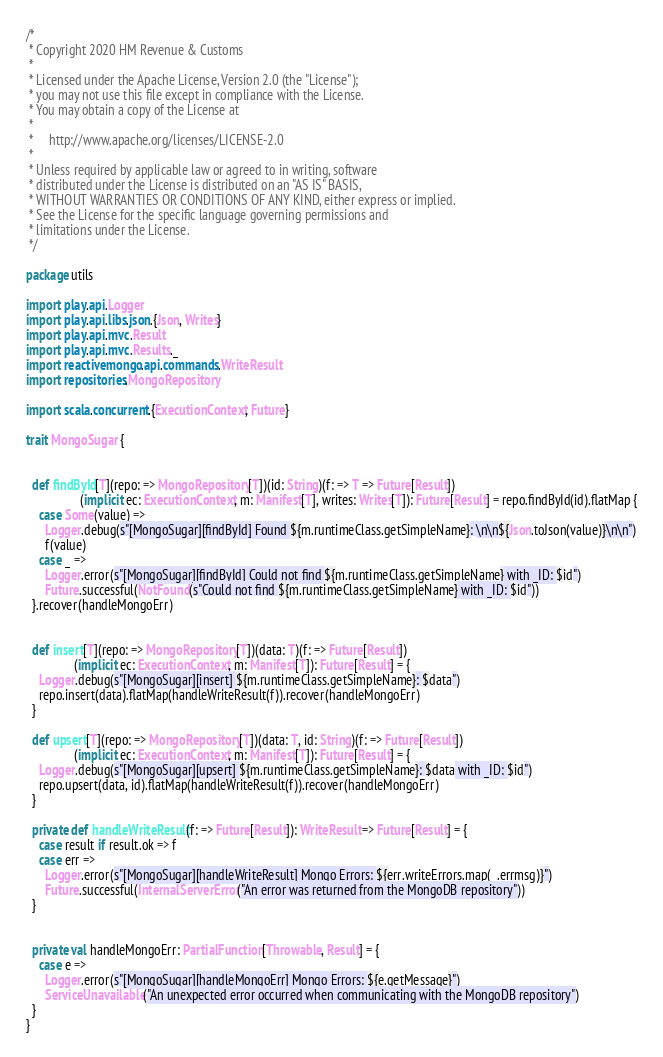Convert code to text. <code><loc_0><loc_0><loc_500><loc_500><_Scala_>/*
 * Copyright 2020 HM Revenue & Customs
 *
 * Licensed under the Apache License, Version 2.0 (the "License");
 * you may not use this file except in compliance with the License.
 * You may obtain a copy of the License at
 *
 *     http://www.apache.org/licenses/LICENSE-2.0
 *
 * Unless required by applicable law or agreed to in writing, software
 * distributed under the License is distributed on an "AS IS" BASIS,
 * WITHOUT WARRANTIES OR CONDITIONS OF ANY KIND, either express or implied.
 * See the License for the specific language governing permissions and
 * limitations under the License.
 */

package utils

import play.api.Logger
import play.api.libs.json.{Json, Writes}
import play.api.mvc.Result
import play.api.mvc.Results._
import reactivemongo.api.commands.WriteResult
import repositories.MongoRepository

import scala.concurrent.{ExecutionContext, Future}

trait MongoSugar {


  def findById[T](repo: => MongoRepository[T])(id: String)(f: => T => Future[Result])
                 (implicit ec: ExecutionContext, m: Manifest[T], writes: Writes[T]): Future[Result] = repo.findById(id).flatMap {
    case Some(value) =>
      Logger.debug(s"[MongoSugar][findById] Found ${m.runtimeClass.getSimpleName}: \n\n${Json.toJson(value)}\n\n")
      f(value)
    case _ =>
      Logger.error(s"[MongoSugar][findById] Could not find ${m.runtimeClass.getSimpleName} with _ID: $id")
      Future.successful(NotFound(s"Could not find ${m.runtimeClass.getSimpleName} with _ID: $id"))
  }.recover(handleMongoErr)


  def insert[T](repo: => MongoRepository[T])(data: T)(f: => Future[Result])
               (implicit ec: ExecutionContext, m: Manifest[T]): Future[Result] = {
    Logger.debug(s"[MongoSugar][insert] ${m.runtimeClass.getSimpleName}: $data")
    repo.insert(data).flatMap(handleWriteResult(f)).recover(handleMongoErr)
  }

  def upsert[T](repo: => MongoRepository[T])(data: T, id: String)(f: => Future[Result])
               (implicit ec: ExecutionContext, m: Manifest[T]): Future[Result] = {
    Logger.debug(s"[MongoSugar][upsert] ${m.runtimeClass.getSimpleName}: $data with _ID: $id")
    repo.upsert(data, id).flatMap(handleWriteResult(f)).recover(handleMongoErr)
  }

  private def handleWriteResult(f: => Future[Result]): WriteResult => Future[Result] = {
    case result if result.ok => f
    case err =>
      Logger.error(s"[MongoSugar][handleWriteResult] Mongo Errors: ${err.writeErrors.map(_.errmsg)}")
      Future.successful(InternalServerError("An error was returned from the MongoDB repository"))
  }


  private val handleMongoErr: PartialFunction[Throwable, Result] = {
    case e =>
      Logger.error(s"[MongoSugar][handleMongoErr] Mongo Errors: ${e.getMessage}")
      ServiceUnavailable("An unexpected error occurred when communicating with the MongoDB repository")
  }
}
</code> 